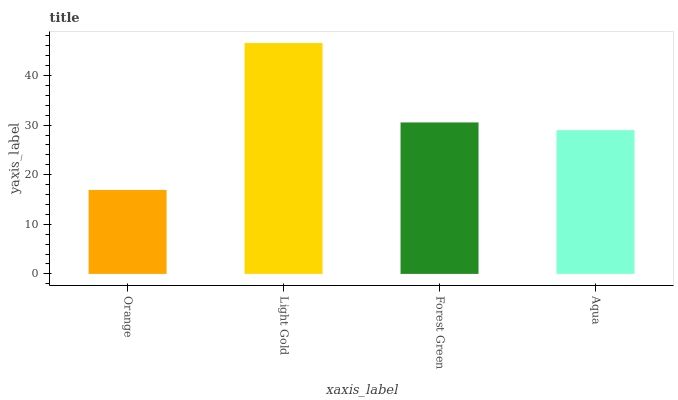Is Forest Green the minimum?
Answer yes or no. No. Is Forest Green the maximum?
Answer yes or no. No. Is Light Gold greater than Forest Green?
Answer yes or no. Yes. Is Forest Green less than Light Gold?
Answer yes or no. Yes. Is Forest Green greater than Light Gold?
Answer yes or no. No. Is Light Gold less than Forest Green?
Answer yes or no. No. Is Forest Green the high median?
Answer yes or no. Yes. Is Aqua the low median?
Answer yes or no. Yes. Is Orange the high median?
Answer yes or no. No. Is Forest Green the low median?
Answer yes or no. No. 